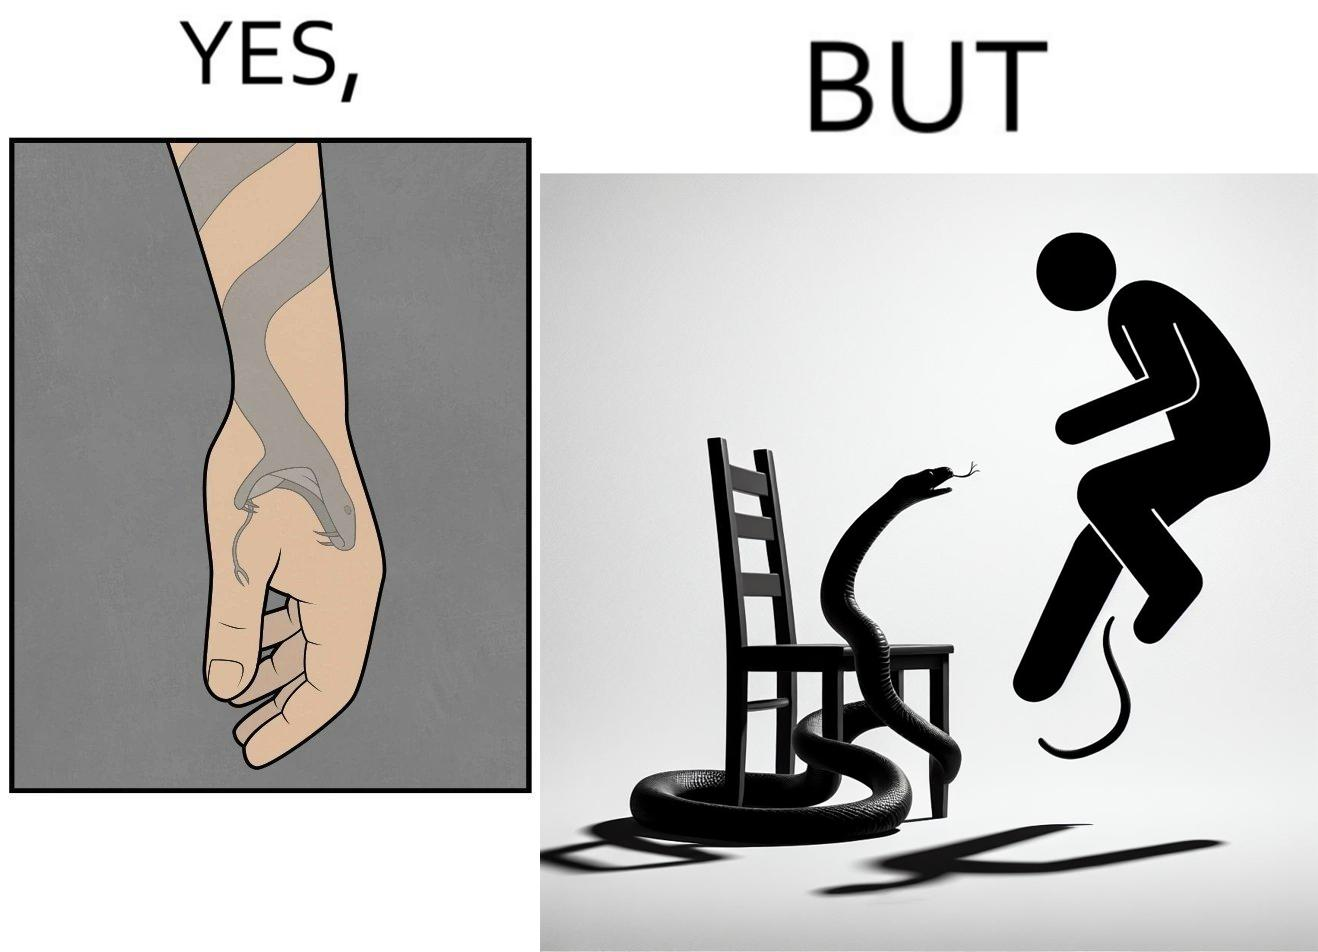What does this image depict? The image is ironic, because in the first image the tattoo of a snake on someone's hand may give us a hint about how powerful or brave the person can be who is having this tattoo but in the second image the person with same tattoo is seen frightened due to a snake in his house 